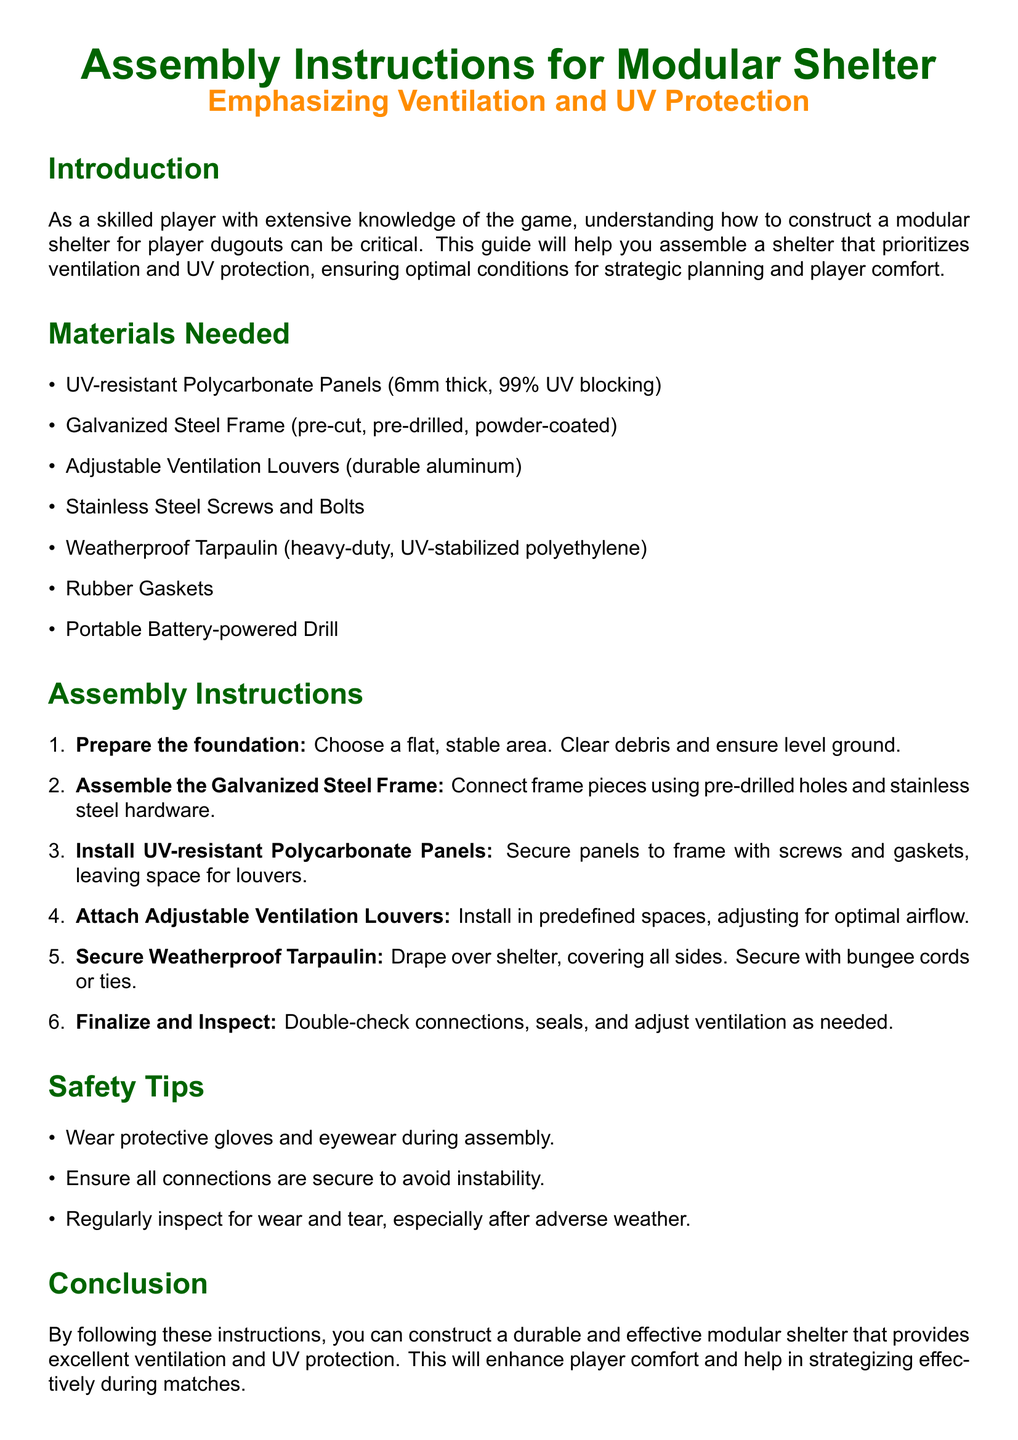What is the thickness of the UV-resistant Polycarbonate Panels? The thickness of the UV-resistant Polycarbonate Panels is specified as 6mm.
Answer: 6mm How many percent of UV does the Polycarbonate Panels block? The document states that the panels block 99% of UV.
Answer: 99% What type of frame is used for the shelter? The frame used for the shelter is a Galvanized Steel Frame, as indicated in the materials section.
Answer: Galvanized Steel Frame What should you ensure about the assembled connections? It is emphasized in the safety tips that all connections should be secure to avoid instability.
Answer: Secure What is the purpose of the Adjustable Ventilation Louvers? The louvers are installed to adjust for optimal airflow, as stated in the assembly instructions.
Answer: Optimal airflow Which tool is required for assembling the shelter? A Portable Battery-powered Drill is listed under materials needed for assembly.
Answer: Portable Battery-powered Drill What is the last step in the assembly instructions? The last step in the assembly instructions is to double-check connections, seals, and adjust ventilation as needed.
Answer: Finalize and Inspect What is the primary focus of this modular shelter? The primary focus of the modular shelter is on ventilation and UV protection according to the title.
Answer: Ventilation and UV protection 